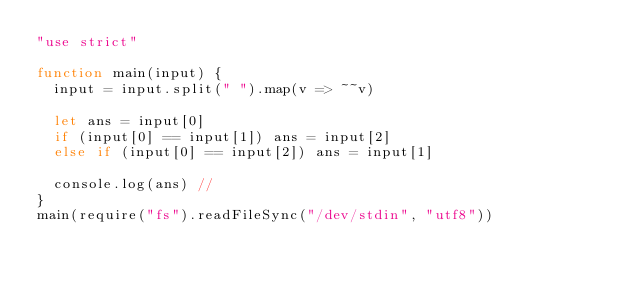Convert code to text. <code><loc_0><loc_0><loc_500><loc_500><_JavaScript_>"use strict"

function main(input) {
  input = input.split(" ").map(v => ~~v)

  let ans = input[0]
  if (input[0] == input[1]) ans = input[2]
  else if (input[0] == input[2]) ans = input[1]

  console.log(ans) //
}
main(require("fs").readFileSync("/dev/stdin", "utf8"))</code> 